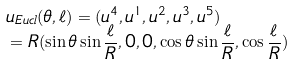Convert formula to latex. <formula><loc_0><loc_0><loc_500><loc_500>& u _ { E u c l } ( \theta , \ell ) = ( u ^ { 4 } , u ^ { 1 } , u ^ { 2 } , u ^ { 3 } , u ^ { 5 } ) \\ & = R ( \sin \theta \sin \frac { \ell } { R } , 0 , 0 , \cos \theta \sin \frac { \ell } { R } , \cos \frac { \ell } { R } )</formula> 